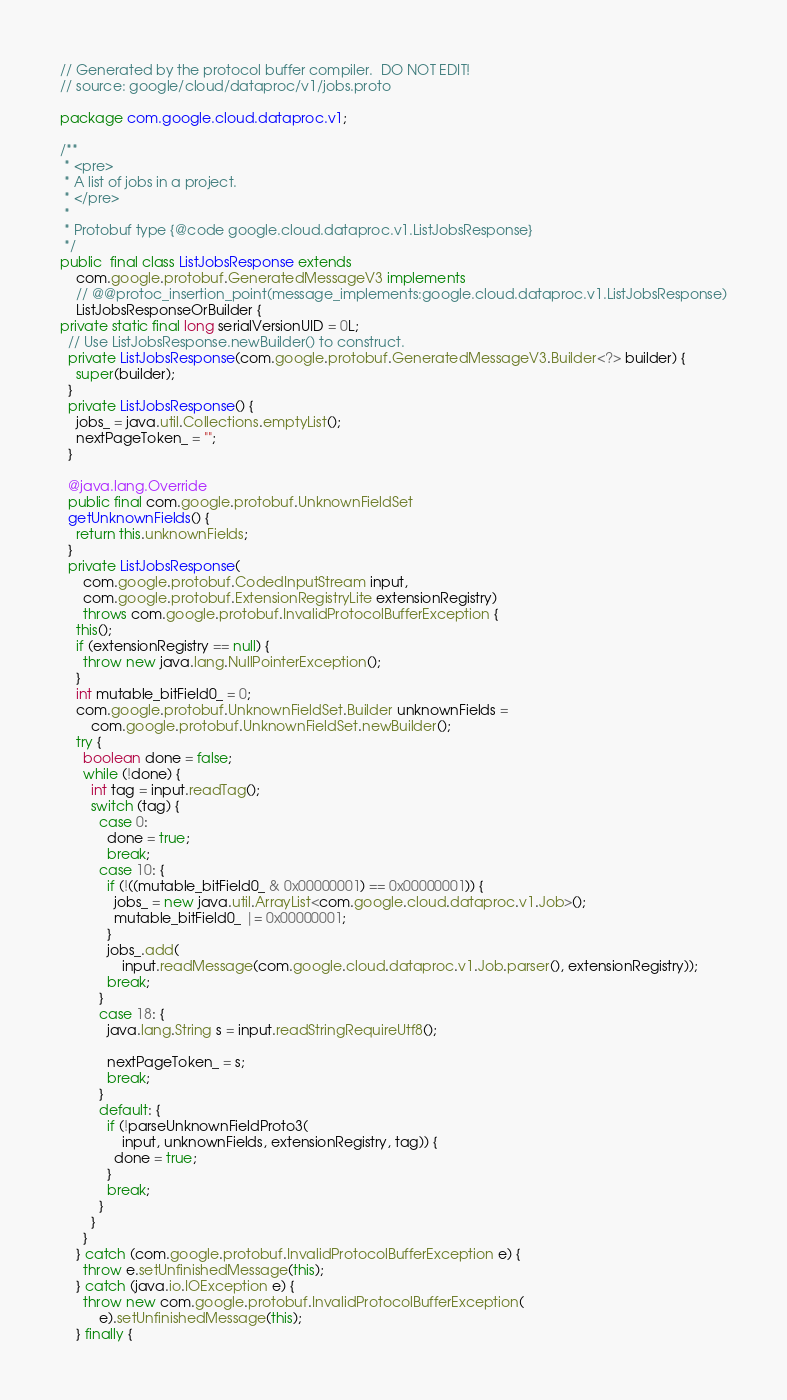<code> <loc_0><loc_0><loc_500><loc_500><_Java_>// Generated by the protocol buffer compiler.  DO NOT EDIT!
// source: google/cloud/dataproc/v1/jobs.proto

package com.google.cloud.dataproc.v1;

/**
 * <pre>
 * A list of jobs in a project.
 * </pre>
 *
 * Protobuf type {@code google.cloud.dataproc.v1.ListJobsResponse}
 */
public  final class ListJobsResponse extends
    com.google.protobuf.GeneratedMessageV3 implements
    // @@protoc_insertion_point(message_implements:google.cloud.dataproc.v1.ListJobsResponse)
    ListJobsResponseOrBuilder {
private static final long serialVersionUID = 0L;
  // Use ListJobsResponse.newBuilder() to construct.
  private ListJobsResponse(com.google.protobuf.GeneratedMessageV3.Builder<?> builder) {
    super(builder);
  }
  private ListJobsResponse() {
    jobs_ = java.util.Collections.emptyList();
    nextPageToken_ = "";
  }

  @java.lang.Override
  public final com.google.protobuf.UnknownFieldSet
  getUnknownFields() {
    return this.unknownFields;
  }
  private ListJobsResponse(
      com.google.protobuf.CodedInputStream input,
      com.google.protobuf.ExtensionRegistryLite extensionRegistry)
      throws com.google.protobuf.InvalidProtocolBufferException {
    this();
    if (extensionRegistry == null) {
      throw new java.lang.NullPointerException();
    }
    int mutable_bitField0_ = 0;
    com.google.protobuf.UnknownFieldSet.Builder unknownFields =
        com.google.protobuf.UnknownFieldSet.newBuilder();
    try {
      boolean done = false;
      while (!done) {
        int tag = input.readTag();
        switch (tag) {
          case 0:
            done = true;
            break;
          case 10: {
            if (!((mutable_bitField0_ & 0x00000001) == 0x00000001)) {
              jobs_ = new java.util.ArrayList<com.google.cloud.dataproc.v1.Job>();
              mutable_bitField0_ |= 0x00000001;
            }
            jobs_.add(
                input.readMessage(com.google.cloud.dataproc.v1.Job.parser(), extensionRegistry));
            break;
          }
          case 18: {
            java.lang.String s = input.readStringRequireUtf8();

            nextPageToken_ = s;
            break;
          }
          default: {
            if (!parseUnknownFieldProto3(
                input, unknownFields, extensionRegistry, tag)) {
              done = true;
            }
            break;
          }
        }
      }
    } catch (com.google.protobuf.InvalidProtocolBufferException e) {
      throw e.setUnfinishedMessage(this);
    } catch (java.io.IOException e) {
      throw new com.google.protobuf.InvalidProtocolBufferException(
          e).setUnfinishedMessage(this);
    } finally {</code> 